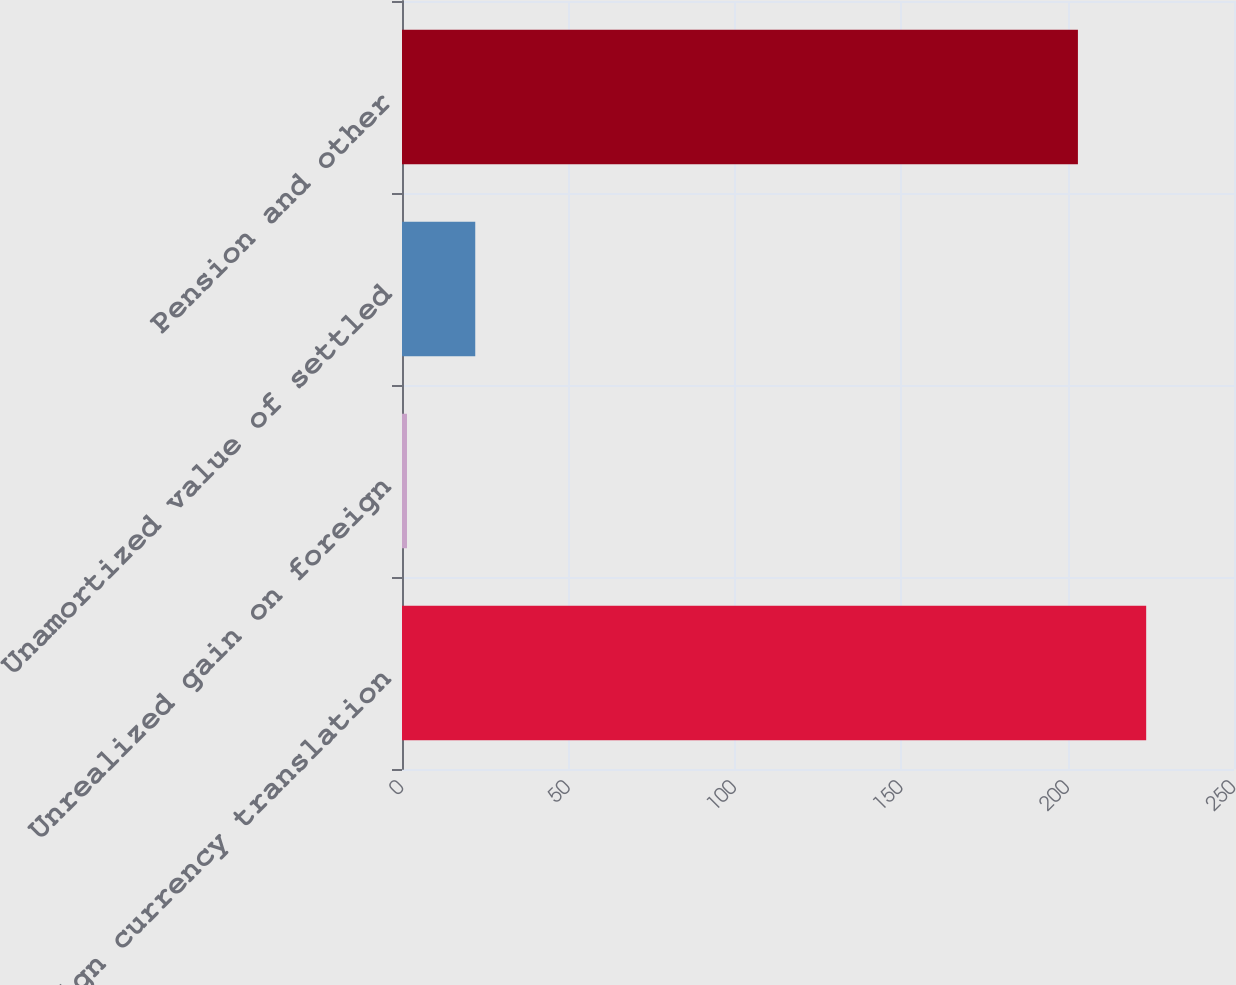Convert chart. <chart><loc_0><loc_0><loc_500><loc_500><bar_chart><fcel>Foreign currency translation<fcel>Unrealized gain on foreign<fcel>Unamortized value of settled<fcel>Pension and other<nl><fcel>223.61<fcel>1.5<fcel>22.01<fcel>203.1<nl></chart> 